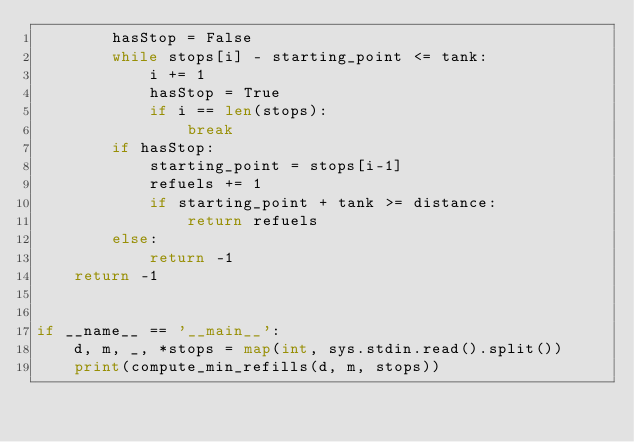<code> <loc_0><loc_0><loc_500><loc_500><_Python_>        hasStop = False
        while stops[i] - starting_point <= tank:
            i += 1
            hasStop = True
            if i == len(stops):
                break
        if hasStop:
            starting_point = stops[i-1]
            refuels += 1
            if starting_point + tank >= distance:
                return refuels
        else:
            return -1
    return -1


if __name__ == '__main__':
    d, m, _, *stops = map(int, sys.stdin.read().split())
    print(compute_min_refills(d, m, stops))
</code> 